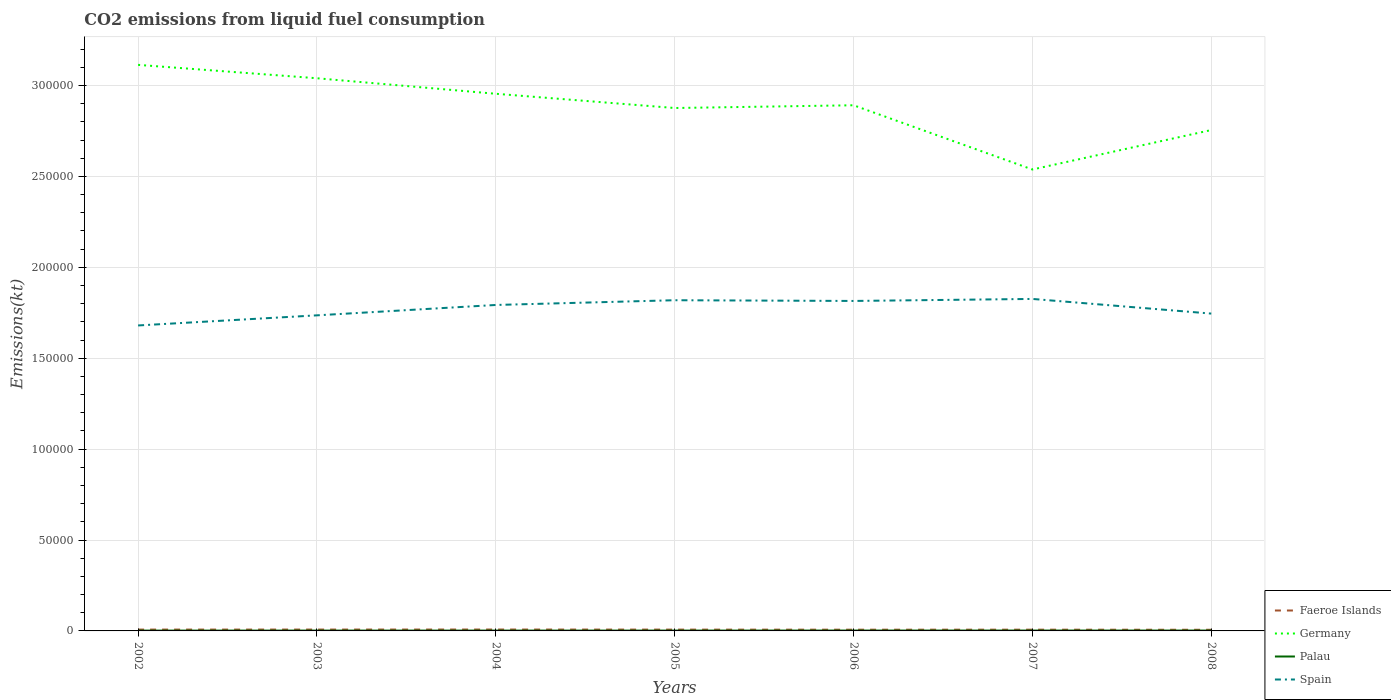How many different coloured lines are there?
Offer a terse response. 4. Across all years, what is the maximum amount of CO2 emitted in Faeroe Islands?
Make the answer very short. 630.72. In which year was the amount of CO2 emitted in Germany maximum?
Your answer should be compact. 2007. What is the total amount of CO2 emitted in Palau in the graph?
Offer a terse response. -18.34. What is the difference between the highest and the second highest amount of CO2 emitted in Palau?
Your answer should be compact. 25.67. What is the difference between the highest and the lowest amount of CO2 emitted in Germany?
Your answer should be very brief. 4. Does the graph contain any zero values?
Your answer should be very brief. No. Does the graph contain grids?
Offer a terse response. Yes. How many legend labels are there?
Your response must be concise. 4. How are the legend labels stacked?
Your answer should be very brief. Vertical. What is the title of the graph?
Your response must be concise. CO2 emissions from liquid fuel consumption. What is the label or title of the X-axis?
Make the answer very short. Years. What is the label or title of the Y-axis?
Give a very brief answer. Emissions(kt). What is the Emissions(kt) of Faeroe Islands in 2002?
Provide a short and direct response. 733.4. What is the Emissions(kt) in Germany in 2002?
Offer a very short reply. 3.11e+05. What is the Emissions(kt) in Palau in 2002?
Your answer should be very brief. 183.35. What is the Emissions(kt) of Spain in 2002?
Provide a short and direct response. 1.68e+05. What is the Emissions(kt) in Faeroe Islands in 2003?
Offer a very short reply. 748.07. What is the Emissions(kt) of Germany in 2003?
Keep it short and to the point. 3.04e+05. What is the Emissions(kt) in Palau in 2003?
Offer a very short reply. 190.68. What is the Emissions(kt) in Spain in 2003?
Ensure brevity in your answer.  1.74e+05. What is the Emissions(kt) of Faeroe Islands in 2004?
Keep it short and to the point. 766.4. What is the Emissions(kt) of Germany in 2004?
Keep it short and to the point. 2.95e+05. What is the Emissions(kt) of Palau in 2004?
Keep it short and to the point. 187.02. What is the Emissions(kt) in Spain in 2004?
Offer a terse response. 1.79e+05. What is the Emissions(kt) in Faeroe Islands in 2005?
Ensure brevity in your answer.  722.4. What is the Emissions(kt) of Germany in 2005?
Keep it short and to the point. 2.88e+05. What is the Emissions(kt) of Palau in 2005?
Offer a terse response. 190.68. What is the Emissions(kt) in Spain in 2005?
Ensure brevity in your answer.  1.82e+05. What is the Emissions(kt) in Faeroe Islands in 2006?
Your response must be concise. 678.39. What is the Emissions(kt) of Germany in 2006?
Keep it short and to the point. 2.89e+05. What is the Emissions(kt) in Palau in 2006?
Give a very brief answer. 201.69. What is the Emissions(kt) in Spain in 2006?
Provide a short and direct response. 1.82e+05. What is the Emissions(kt) in Faeroe Islands in 2007?
Provide a short and direct response. 689.4. What is the Emissions(kt) of Germany in 2007?
Ensure brevity in your answer.  2.54e+05. What is the Emissions(kt) of Palau in 2007?
Your answer should be very brief. 209.02. What is the Emissions(kt) in Spain in 2007?
Provide a succinct answer. 1.83e+05. What is the Emissions(kt) of Faeroe Islands in 2008?
Your answer should be compact. 630.72. What is the Emissions(kt) of Germany in 2008?
Provide a succinct answer. 2.76e+05. What is the Emissions(kt) of Palau in 2008?
Ensure brevity in your answer.  209.02. What is the Emissions(kt) of Spain in 2008?
Your response must be concise. 1.75e+05. Across all years, what is the maximum Emissions(kt) of Faeroe Islands?
Offer a terse response. 766.4. Across all years, what is the maximum Emissions(kt) in Germany?
Offer a terse response. 3.11e+05. Across all years, what is the maximum Emissions(kt) of Palau?
Offer a terse response. 209.02. Across all years, what is the maximum Emissions(kt) of Spain?
Your answer should be very brief. 1.83e+05. Across all years, what is the minimum Emissions(kt) of Faeroe Islands?
Ensure brevity in your answer.  630.72. Across all years, what is the minimum Emissions(kt) of Germany?
Ensure brevity in your answer.  2.54e+05. Across all years, what is the minimum Emissions(kt) in Palau?
Your answer should be very brief. 183.35. Across all years, what is the minimum Emissions(kt) in Spain?
Make the answer very short. 1.68e+05. What is the total Emissions(kt) of Faeroe Islands in the graph?
Offer a terse response. 4968.78. What is the total Emissions(kt) of Germany in the graph?
Offer a terse response. 2.02e+06. What is the total Emissions(kt) of Palau in the graph?
Make the answer very short. 1371.46. What is the total Emissions(kt) of Spain in the graph?
Ensure brevity in your answer.  1.24e+06. What is the difference between the Emissions(kt) of Faeroe Islands in 2002 and that in 2003?
Give a very brief answer. -14.67. What is the difference between the Emissions(kt) in Germany in 2002 and that in 2003?
Provide a short and direct response. 7367. What is the difference between the Emissions(kt) in Palau in 2002 and that in 2003?
Your response must be concise. -7.33. What is the difference between the Emissions(kt) of Spain in 2002 and that in 2003?
Your answer should be very brief. -5566.51. What is the difference between the Emissions(kt) in Faeroe Islands in 2002 and that in 2004?
Provide a succinct answer. -33. What is the difference between the Emissions(kt) in Germany in 2002 and that in 2004?
Ensure brevity in your answer.  1.59e+04. What is the difference between the Emissions(kt) in Palau in 2002 and that in 2004?
Keep it short and to the point. -3.67. What is the difference between the Emissions(kt) in Spain in 2002 and that in 2004?
Offer a very short reply. -1.13e+04. What is the difference between the Emissions(kt) of Faeroe Islands in 2002 and that in 2005?
Give a very brief answer. 11. What is the difference between the Emissions(kt) in Germany in 2002 and that in 2005?
Ensure brevity in your answer.  2.37e+04. What is the difference between the Emissions(kt) of Palau in 2002 and that in 2005?
Provide a succinct answer. -7.33. What is the difference between the Emissions(kt) in Spain in 2002 and that in 2005?
Provide a succinct answer. -1.39e+04. What is the difference between the Emissions(kt) in Faeroe Islands in 2002 and that in 2006?
Your answer should be very brief. 55.01. What is the difference between the Emissions(kt) of Germany in 2002 and that in 2006?
Keep it short and to the point. 2.22e+04. What is the difference between the Emissions(kt) of Palau in 2002 and that in 2006?
Give a very brief answer. -18.34. What is the difference between the Emissions(kt) of Spain in 2002 and that in 2006?
Keep it short and to the point. -1.35e+04. What is the difference between the Emissions(kt) in Faeroe Islands in 2002 and that in 2007?
Make the answer very short. 44. What is the difference between the Emissions(kt) of Germany in 2002 and that in 2007?
Offer a very short reply. 5.76e+04. What is the difference between the Emissions(kt) in Palau in 2002 and that in 2007?
Give a very brief answer. -25.67. What is the difference between the Emissions(kt) in Spain in 2002 and that in 2007?
Give a very brief answer. -1.46e+04. What is the difference between the Emissions(kt) of Faeroe Islands in 2002 and that in 2008?
Your answer should be compact. 102.68. What is the difference between the Emissions(kt) in Germany in 2002 and that in 2008?
Provide a succinct answer. 3.59e+04. What is the difference between the Emissions(kt) in Palau in 2002 and that in 2008?
Offer a terse response. -25.67. What is the difference between the Emissions(kt) in Spain in 2002 and that in 2008?
Provide a short and direct response. -6527.26. What is the difference between the Emissions(kt) in Faeroe Islands in 2003 and that in 2004?
Offer a very short reply. -18.34. What is the difference between the Emissions(kt) of Germany in 2003 and that in 2004?
Your response must be concise. 8536.78. What is the difference between the Emissions(kt) of Palau in 2003 and that in 2004?
Keep it short and to the point. 3.67. What is the difference between the Emissions(kt) in Spain in 2003 and that in 2004?
Offer a terse response. -5705.85. What is the difference between the Emissions(kt) in Faeroe Islands in 2003 and that in 2005?
Offer a very short reply. 25.67. What is the difference between the Emissions(kt) in Germany in 2003 and that in 2005?
Ensure brevity in your answer.  1.64e+04. What is the difference between the Emissions(kt) of Palau in 2003 and that in 2005?
Offer a very short reply. 0. What is the difference between the Emissions(kt) in Spain in 2003 and that in 2005?
Your answer should be compact. -8309.42. What is the difference between the Emissions(kt) in Faeroe Islands in 2003 and that in 2006?
Offer a very short reply. 69.67. What is the difference between the Emissions(kt) of Germany in 2003 and that in 2006?
Offer a terse response. 1.49e+04. What is the difference between the Emissions(kt) in Palau in 2003 and that in 2006?
Your answer should be very brief. -11. What is the difference between the Emissions(kt) of Spain in 2003 and that in 2006?
Your answer should be very brief. -7913.39. What is the difference between the Emissions(kt) of Faeroe Islands in 2003 and that in 2007?
Give a very brief answer. 58.67. What is the difference between the Emissions(kt) in Germany in 2003 and that in 2007?
Give a very brief answer. 5.02e+04. What is the difference between the Emissions(kt) of Palau in 2003 and that in 2007?
Keep it short and to the point. -18.34. What is the difference between the Emissions(kt) of Spain in 2003 and that in 2007?
Give a very brief answer. -9024.49. What is the difference between the Emissions(kt) of Faeroe Islands in 2003 and that in 2008?
Provide a succinct answer. 117.34. What is the difference between the Emissions(kt) of Germany in 2003 and that in 2008?
Make the answer very short. 2.85e+04. What is the difference between the Emissions(kt) of Palau in 2003 and that in 2008?
Your response must be concise. -18.34. What is the difference between the Emissions(kt) of Spain in 2003 and that in 2008?
Provide a succinct answer. -960.75. What is the difference between the Emissions(kt) in Faeroe Islands in 2004 and that in 2005?
Your response must be concise. 44. What is the difference between the Emissions(kt) of Germany in 2004 and that in 2005?
Provide a short and direct response. 7832.71. What is the difference between the Emissions(kt) of Palau in 2004 and that in 2005?
Provide a succinct answer. -3.67. What is the difference between the Emissions(kt) of Spain in 2004 and that in 2005?
Ensure brevity in your answer.  -2603.57. What is the difference between the Emissions(kt) in Faeroe Islands in 2004 and that in 2006?
Ensure brevity in your answer.  88.01. What is the difference between the Emissions(kt) of Germany in 2004 and that in 2006?
Provide a short and direct response. 6318.24. What is the difference between the Emissions(kt) in Palau in 2004 and that in 2006?
Your response must be concise. -14.67. What is the difference between the Emissions(kt) of Spain in 2004 and that in 2006?
Your response must be concise. -2207.53. What is the difference between the Emissions(kt) of Faeroe Islands in 2004 and that in 2007?
Your answer should be very brief. 77.01. What is the difference between the Emissions(kt) of Germany in 2004 and that in 2007?
Provide a succinct answer. 4.17e+04. What is the difference between the Emissions(kt) in Palau in 2004 and that in 2007?
Offer a terse response. -22. What is the difference between the Emissions(kt) in Spain in 2004 and that in 2007?
Provide a succinct answer. -3318.64. What is the difference between the Emissions(kt) of Faeroe Islands in 2004 and that in 2008?
Provide a short and direct response. 135.68. What is the difference between the Emissions(kt) in Germany in 2004 and that in 2008?
Offer a very short reply. 2.00e+04. What is the difference between the Emissions(kt) of Palau in 2004 and that in 2008?
Your response must be concise. -22. What is the difference between the Emissions(kt) of Spain in 2004 and that in 2008?
Provide a short and direct response. 4745.1. What is the difference between the Emissions(kt) of Faeroe Islands in 2005 and that in 2006?
Provide a short and direct response. 44. What is the difference between the Emissions(kt) in Germany in 2005 and that in 2006?
Keep it short and to the point. -1514.47. What is the difference between the Emissions(kt) in Palau in 2005 and that in 2006?
Give a very brief answer. -11. What is the difference between the Emissions(kt) of Spain in 2005 and that in 2006?
Your response must be concise. 396.04. What is the difference between the Emissions(kt) of Faeroe Islands in 2005 and that in 2007?
Your answer should be very brief. 33. What is the difference between the Emissions(kt) in Germany in 2005 and that in 2007?
Provide a short and direct response. 3.38e+04. What is the difference between the Emissions(kt) of Palau in 2005 and that in 2007?
Offer a terse response. -18.34. What is the difference between the Emissions(kt) of Spain in 2005 and that in 2007?
Offer a terse response. -715.07. What is the difference between the Emissions(kt) of Faeroe Islands in 2005 and that in 2008?
Provide a succinct answer. 91.67. What is the difference between the Emissions(kt) of Germany in 2005 and that in 2008?
Provide a short and direct response. 1.21e+04. What is the difference between the Emissions(kt) of Palau in 2005 and that in 2008?
Make the answer very short. -18.34. What is the difference between the Emissions(kt) of Spain in 2005 and that in 2008?
Provide a short and direct response. 7348.67. What is the difference between the Emissions(kt) of Faeroe Islands in 2006 and that in 2007?
Make the answer very short. -11. What is the difference between the Emissions(kt) in Germany in 2006 and that in 2007?
Your answer should be very brief. 3.53e+04. What is the difference between the Emissions(kt) of Palau in 2006 and that in 2007?
Your answer should be very brief. -7.33. What is the difference between the Emissions(kt) in Spain in 2006 and that in 2007?
Keep it short and to the point. -1111.1. What is the difference between the Emissions(kt) of Faeroe Islands in 2006 and that in 2008?
Keep it short and to the point. 47.67. What is the difference between the Emissions(kt) of Germany in 2006 and that in 2008?
Ensure brevity in your answer.  1.36e+04. What is the difference between the Emissions(kt) of Palau in 2006 and that in 2008?
Provide a short and direct response. -7.33. What is the difference between the Emissions(kt) of Spain in 2006 and that in 2008?
Your answer should be very brief. 6952.63. What is the difference between the Emissions(kt) in Faeroe Islands in 2007 and that in 2008?
Your answer should be very brief. 58.67. What is the difference between the Emissions(kt) of Germany in 2007 and that in 2008?
Offer a terse response. -2.17e+04. What is the difference between the Emissions(kt) of Spain in 2007 and that in 2008?
Make the answer very short. 8063.73. What is the difference between the Emissions(kt) of Faeroe Islands in 2002 and the Emissions(kt) of Germany in 2003?
Your answer should be very brief. -3.03e+05. What is the difference between the Emissions(kt) in Faeroe Islands in 2002 and the Emissions(kt) in Palau in 2003?
Your response must be concise. 542.72. What is the difference between the Emissions(kt) in Faeroe Islands in 2002 and the Emissions(kt) in Spain in 2003?
Your answer should be compact. -1.73e+05. What is the difference between the Emissions(kt) in Germany in 2002 and the Emissions(kt) in Palau in 2003?
Ensure brevity in your answer.  3.11e+05. What is the difference between the Emissions(kt) in Germany in 2002 and the Emissions(kt) in Spain in 2003?
Give a very brief answer. 1.38e+05. What is the difference between the Emissions(kt) in Palau in 2002 and the Emissions(kt) in Spain in 2003?
Ensure brevity in your answer.  -1.73e+05. What is the difference between the Emissions(kt) in Faeroe Islands in 2002 and the Emissions(kt) in Germany in 2004?
Ensure brevity in your answer.  -2.95e+05. What is the difference between the Emissions(kt) in Faeroe Islands in 2002 and the Emissions(kt) in Palau in 2004?
Provide a succinct answer. 546.38. What is the difference between the Emissions(kt) of Faeroe Islands in 2002 and the Emissions(kt) of Spain in 2004?
Ensure brevity in your answer.  -1.79e+05. What is the difference between the Emissions(kt) of Germany in 2002 and the Emissions(kt) of Palau in 2004?
Make the answer very short. 3.11e+05. What is the difference between the Emissions(kt) of Germany in 2002 and the Emissions(kt) of Spain in 2004?
Offer a terse response. 1.32e+05. What is the difference between the Emissions(kt) in Palau in 2002 and the Emissions(kt) in Spain in 2004?
Provide a succinct answer. -1.79e+05. What is the difference between the Emissions(kt) in Faeroe Islands in 2002 and the Emissions(kt) in Germany in 2005?
Make the answer very short. -2.87e+05. What is the difference between the Emissions(kt) in Faeroe Islands in 2002 and the Emissions(kt) in Palau in 2005?
Provide a short and direct response. 542.72. What is the difference between the Emissions(kt) in Faeroe Islands in 2002 and the Emissions(kt) in Spain in 2005?
Offer a very short reply. -1.81e+05. What is the difference between the Emissions(kt) of Germany in 2002 and the Emissions(kt) of Palau in 2005?
Make the answer very short. 3.11e+05. What is the difference between the Emissions(kt) of Germany in 2002 and the Emissions(kt) of Spain in 2005?
Your answer should be very brief. 1.29e+05. What is the difference between the Emissions(kt) of Palau in 2002 and the Emissions(kt) of Spain in 2005?
Give a very brief answer. -1.82e+05. What is the difference between the Emissions(kt) in Faeroe Islands in 2002 and the Emissions(kt) in Germany in 2006?
Provide a succinct answer. -2.88e+05. What is the difference between the Emissions(kt) in Faeroe Islands in 2002 and the Emissions(kt) in Palau in 2006?
Make the answer very short. 531.72. What is the difference between the Emissions(kt) of Faeroe Islands in 2002 and the Emissions(kt) of Spain in 2006?
Keep it short and to the point. -1.81e+05. What is the difference between the Emissions(kt) in Germany in 2002 and the Emissions(kt) in Palau in 2006?
Keep it short and to the point. 3.11e+05. What is the difference between the Emissions(kt) of Germany in 2002 and the Emissions(kt) of Spain in 2006?
Provide a short and direct response. 1.30e+05. What is the difference between the Emissions(kt) of Palau in 2002 and the Emissions(kt) of Spain in 2006?
Your answer should be very brief. -1.81e+05. What is the difference between the Emissions(kt) in Faeroe Islands in 2002 and the Emissions(kt) in Germany in 2007?
Provide a short and direct response. -2.53e+05. What is the difference between the Emissions(kt) in Faeroe Islands in 2002 and the Emissions(kt) in Palau in 2007?
Ensure brevity in your answer.  524.38. What is the difference between the Emissions(kt) of Faeroe Islands in 2002 and the Emissions(kt) of Spain in 2007?
Keep it short and to the point. -1.82e+05. What is the difference between the Emissions(kt) of Germany in 2002 and the Emissions(kt) of Palau in 2007?
Provide a short and direct response. 3.11e+05. What is the difference between the Emissions(kt) of Germany in 2002 and the Emissions(kt) of Spain in 2007?
Offer a very short reply. 1.29e+05. What is the difference between the Emissions(kt) in Palau in 2002 and the Emissions(kt) in Spain in 2007?
Provide a short and direct response. -1.82e+05. What is the difference between the Emissions(kt) in Faeroe Islands in 2002 and the Emissions(kt) in Germany in 2008?
Provide a short and direct response. -2.75e+05. What is the difference between the Emissions(kt) of Faeroe Islands in 2002 and the Emissions(kt) of Palau in 2008?
Offer a very short reply. 524.38. What is the difference between the Emissions(kt) of Faeroe Islands in 2002 and the Emissions(kt) of Spain in 2008?
Offer a very short reply. -1.74e+05. What is the difference between the Emissions(kt) in Germany in 2002 and the Emissions(kt) in Palau in 2008?
Give a very brief answer. 3.11e+05. What is the difference between the Emissions(kt) of Germany in 2002 and the Emissions(kt) of Spain in 2008?
Provide a succinct answer. 1.37e+05. What is the difference between the Emissions(kt) in Palau in 2002 and the Emissions(kt) in Spain in 2008?
Your answer should be very brief. -1.74e+05. What is the difference between the Emissions(kt) of Faeroe Islands in 2003 and the Emissions(kt) of Germany in 2004?
Keep it short and to the point. -2.95e+05. What is the difference between the Emissions(kt) in Faeroe Islands in 2003 and the Emissions(kt) in Palau in 2004?
Make the answer very short. 561.05. What is the difference between the Emissions(kt) in Faeroe Islands in 2003 and the Emissions(kt) in Spain in 2004?
Ensure brevity in your answer.  -1.79e+05. What is the difference between the Emissions(kt) in Germany in 2003 and the Emissions(kt) in Palau in 2004?
Provide a short and direct response. 3.04e+05. What is the difference between the Emissions(kt) in Germany in 2003 and the Emissions(kt) in Spain in 2004?
Provide a short and direct response. 1.25e+05. What is the difference between the Emissions(kt) of Palau in 2003 and the Emissions(kt) of Spain in 2004?
Make the answer very short. -1.79e+05. What is the difference between the Emissions(kt) in Faeroe Islands in 2003 and the Emissions(kt) in Germany in 2005?
Your answer should be very brief. -2.87e+05. What is the difference between the Emissions(kt) in Faeroe Islands in 2003 and the Emissions(kt) in Palau in 2005?
Offer a terse response. 557.38. What is the difference between the Emissions(kt) of Faeroe Islands in 2003 and the Emissions(kt) of Spain in 2005?
Provide a succinct answer. -1.81e+05. What is the difference between the Emissions(kt) of Germany in 2003 and the Emissions(kt) of Palau in 2005?
Provide a short and direct response. 3.04e+05. What is the difference between the Emissions(kt) in Germany in 2003 and the Emissions(kt) in Spain in 2005?
Provide a short and direct response. 1.22e+05. What is the difference between the Emissions(kt) of Palau in 2003 and the Emissions(kt) of Spain in 2005?
Your response must be concise. -1.82e+05. What is the difference between the Emissions(kt) in Faeroe Islands in 2003 and the Emissions(kt) in Germany in 2006?
Ensure brevity in your answer.  -2.88e+05. What is the difference between the Emissions(kt) in Faeroe Islands in 2003 and the Emissions(kt) in Palau in 2006?
Provide a succinct answer. 546.38. What is the difference between the Emissions(kt) in Faeroe Islands in 2003 and the Emissions(kt) in Spain in 2006?
Provide a short and direct response. -1.81e+05. What is the difference between the Emissions(kt) in Germany in 2003 and the Emissions(kt) in Palau in 2006?
Give a very brief answer. 3.04e+05. What is the difference between the Emissions(kt) in Germany in 2003 and the Emissions(kt) in Spain in 2006?
Keep it short and to the point. 1.22e+05. What is the difference between the Emissions(kt) in Palau in 2003 and the Emissions(kt) in Spain in 2006?
Provide a succinct answer. -1.81e+05. What is the difference between the Emissions(kt) in Faeroe Islands in 2003 and the Emissions(kt) in Germany in 2007?
Ensure brevity in your answer.  -2.53e+05. What is the difference between the Emissions(kt) of Faeroe Islands in 2003 and the Emissions(kt) of Palau in 2007?
Offer a terse response. 539.05. What is the difference between the Emissions(kt) in Faeroe Islands in 2003 and the Emissions(kt) in Spain in 2007?
Offer a very short reply. -1.82e+05. What is the difference between the Emissions(kt) in Germany in 2003 and the Emissions(kt) in Palau in 2007?
Offer a very short reply. 3.04e+05. What is the difference between the Emissions(kt) in Germany in 2003 and the Emissions(kt) in Spain in 2007?
Ensure brevity in your answer.  1.21e+05. What is the difference between the Emissions(kt) in Palau in 2003 and the Emissions(kt) in Spain in 2007?
Provide a short and direct response. -1.82e+05. What is the difference between the Emissions(kt) of Faeroe Islands in 2003 and the Emissions(kt) of Germany in 2008?
Provide a succinct answer. -2.75e+05. What is the difference between the Emissions(kt) of Faeroe Islands in 2003 and the Emissions(kt) of Palau in 2008?
Ensure brevity in your answer.  539.05. What is the difference between the Emissions(kt) in Faeroe Islands in 2003 and the Emissions(kt) in Spain in 2008?
Give a very brief answer. -1.74e+05. What is the difference between the Emissions(kt) in Germany in 2003 and the Emissions(kt) in Palau in 2008?
Give a very brief answer. 3.04e+05. What is the difference between the Emissions(kt) of Germany in 2003 and the Emissions(kt) of Spain in 2008?
Make the answer very short. 1.29e+05. What is the difference between the Emissions(kt) of Palau in 2003 and the Emissions(kt) of Spain in 2008?
Your response must be concise. -1.74e+05. What is the difference between the Emissions(kt) of Faeroe Islands in 2004 and the Emissions(kt) of Germany in 2005?
Make the answer very short. -2.87e+05. What is the difference between the Emissions(kt) of Faeroe Islands in 2004 and the Emissions(kt) of Palau in 2005?
Your answer should be very brief. 575.72. What is the difference between the Emissions(kt) of Faeroe Islands in 2004 and the Emissions(kt) of Spain in 2005?
Provide a short and direct response. -1.81e+05. What is the difference between the Emissions(kt) of Germany in 2004 and the Emissions(kt) of Palau in 2005?
Make the answer very short. 2.95e+05. What is the difference between the Emissions(kt) of Germany in 2004 and the Emissions(kt) of Spain in 2005?
Your answer should be compact. 1.14e+05. What is the difference between the Emissions(kt) in Palau in 2004 and the Emissions(kt) in Spain in 2005?
Your answer should be compact. -1.82e+05. What is the difference between the Emissions(kt) in Faeroe Islands in 2004 and the Emissions(kt) in Germany in 2006?
Provide a succinct answer. -2.88e+05. What is the difference between the Emissions(kt) in Faeroe Islands in 2004 and the Emissions(kt) in Palau in 2006?
Your response must be concise. 564.72. What is the difference between the Emissions(kt) in Faeroe Islands in 2004 and the Emissions(kt) in Spain in 2006?
Provide a succinct answer. -1.81e+05. What is the difference between the Emissions(kt) of Germany in 2004 and the Emissions(kt) of Palau in 2006?
Offer a terse response. 2.95e+05. What is the difference between the Emissions(kt) of Germany in 2004 and the Emissions(kt) of Spain in 2006?
Provide a short and direct response. 1.14e+05. What is the difference between the Emissions(kt) of Palau in 2004 and the Emissions(kt) of Spain in 2006?
Offer a terse response. -1.81e+05. What is the difference between the Emissions(kt) of Faeroe Islands in 2004 and the Emissions(kt) of Germany in 2007?
Make the answer very short. -2.53e+05. What is the difference between the Emissions(kt) in Faeroe Islands in 2004 and the Emissions(kt) in Palau in 2007?
Keep it short and to the point. 557.38. What is the difference between the Emissions(kt) of Faeroe Islands in 2004 and the Emissions(kt) of Spain in 2007?
Offer a terse response. -1.82e+05. What is the difference between the Emissions(kt) in Germany in 2004 and the Emissions(kt) in Palau in 2007?
Offer a terse response. 2.95e+05. What is the difference between the Emissions(kt) of Germany in 2004 and the Emissions(kt) of Spain in 2007?
Offer a terse response. 1.13e+05. What is the difference between the Emissions(kt) of Palau in 2004 and the Emissions(kt) of Spain in 2007?
Provide a short and direct response. -1.82e+05. What is the difference between the Emissions(kt) in Faeroe Islands in 2004 and the Emissions(kt) in Germany in 2008?
Ensure brevity in your answer.  -2.75e+05. What is the difference between the Emissions(kt) in Faeroe Islands in 2004 and the Emissions(kt) in Palau in 2008?
Ensure brevity in your answer.  557.38. What is the difference between the Emissions(kt) in Faeroe Islands in 2004 and the Emissions(kt) in Spain in 2008?
Your response must be concise. -1.74e+05. What is the difference between the Emissions(kt) of Germany in 2004 and the Emissions(kt) of Palau in 2008?
Ensure brevity in your answer.  2.95e+05. What is the difference between the Emissions(kt) in Germany in 2004 and the Emissions(kt) in Spain in 2008?
Give a very brief answer. 1.21e+05. What is the difference between the Emissions(kt) in Palau in 2004 and the Emissions(kt) in Spain in 2008?
Give a very brief answer. -1.74e+05. What is the difference between the Emissions(kt) of Faeroe Islands in 2005 and the Emissions(kt) of Germany in 2006?
Your answer should be very brief. -2.88e+05. What is the difference between the Emissions(kt) of Faeroe Islands in 2005 and the Emissions(kt) of Palau in 2006?
Give a very brief answer. 520.71. What is the difference between the Emissions(kt) of Faeroe Islands in 2005 and the Emissions(kt) of Spain in 2006?
Give a very brief answer. -1.81e+05. What is the difference between the Emissions(kt) of Germany in 2005 and the Emissions(kt) of Palau in 2006?
Offer a very short reply. 2.87e+05. What is the difference between the Emissions(kt) of Germany in 2005 and the Emissions(kt) of Spain in 2006?
Your answer should be compact. 1.06e+05. What is the difference between the Emissions(kt) of Palau in 2005 and the Emissions(kt) of Spain in 2006?
Provide a succinct answer. -1.81e+05. What is the difference between the Emissions(kt) in Faeroe Islands in 2005 and the Emissions(kt) in Germany in 2007?
Ensure brevity in your answer.  -2.53e+05. What is the difference between the Emissions(kt) of Faeroe Islands in 2005 and the Emissions(kt) of Palau in 2007?
Offer a very short reply. 513.38. What is the difference between the Emissions(kt) in Faeroe Islands in 2005 and the Emissions(kt) in Spain in 2007?
Offer a very short reply. -1.82e+05. What is the difference between the Emissions(kt) of Germany in 2005 and the Emissions(kt) of Palau in 2007?
Provide a short and direct response. 2.87e+05. What is the difference between the Emissions(kt) of Germany in 2005 and the Emissions(kt) of Spain in 2007?
Make the answer very short. 1.05e+05. What is the difference between the Emissions(kt) in Palau in 2005 and the Emissions(kt) in Spain in 2007?
Provide a succinct answer. -1.82e+05. What is the difference between the Emissions(kt) of Faeroe Islands in 2005 and the Emissions(kt) of Germany in 2008?
Provide a short and direct response. -2.75e+05. What is the difference between the Emissions(kt) of Faeroe Islands in 2005 and the Emissions(kt) of Palau in 2008?
Provide a short and direct response. 513.38. What is the difference between the Emissions(kt) in Faeroe Islands in 2005 and the Emissions(kt) in Spain in 2008?
Give a very brief answer. -1.74e+05. What is the difference between the Emissions(kt) of Germany in 2005 and the Emissions(kt) of Palau in 2008?
Give a very brief answer. 2.87e+05. What is the difference between the Emissions(kt) of Germany in 2005 and the Emissions(kt) of Spain in 2008?
Make the answer very short. 1.13e+05. What is the difference between the Emissions(kt) of Palau in 2005 and the Emissions(kt) of Spain in 2008?
Give a very brief answer. -1.74e+05. What is the difference between the Emissions(kt) in Faeroe Islands in 2006 and the Emissions(kt) in Germany in 2007?
Offer a terse response. -2.53e+05. What is the difference between the Emissions(kt) of Faeroe Islands in 2006 and the Emissions(kt) of Palau in 2007?
Make the answer very short. 469.38. What is the difference between the Emissions(kt) in Faeroe Islands in 2006 and the Emissions(kt) in Spain in 2007?
Your response must be concise. -1.82e+05. What is the difference between the Emissions(kt) of Germany in 2006 and the Emissions(kt) of Palau in 2007?
Ensure brevity in your answer.  2.89e+05. What is the difference between the Emissions(kt) of Germany in 2006 and the Emissions(kt) of Spain in 2007?
Offer a very short reply. 1.07e+05. What is the difference between the Emissions(kt) of Palau in 2006 and the Emissions(kt) of Spain in 2007?
Your answer should be compact. -1.82e+05. What is the difference between the Emissions(kt) in Faeroe Islands in 2006 and the Emissions(kt) in Germany in 2008?
Provide a succinct answer. -2.75e+05. What is the difference between the Emissions(kt) in Faeroe Islands in 2006 and the Emissions(kt) in Palau in 2008?
Provide a succinct answer. 469.38. What is the difference between the Emissions(kt) in Faeroe Islands in 2006 and the Emissions(kt) in Spain in 2008?
Provide a short and direct response. -1.74e+05. What is the difference between the Emissions(kt) in Germany in 2006 and the Emissions(kt) in Palau in 2008?
Offer a very short reply. 2.89e+05. What is the difference between the Emissions(kt) of Germany in 2006 and the Emissions(kt) of Spain in 2008?
Provide a short and direct response. 1.15e+05. What is the difference between the Emissions(kt) of Palau in 2006 and the Emissions(kt) of Spain in 2008?
Provide a short and direct response. -1.74e+05. What is the difference between the Emissions(kt) of Faeroe Islands in 2007 and the Emissions(kt) of Germany in 2008?
Give a very brief answer. -2.75e+05. What is the difference between the Emissions(kt) in Faeroe Islands in 2007 and the Emissions(kt) in Palau in 2008?
Your answer should be compact. 480.38. What is the difference between the Emissions(kt) of Faeroe Islands in 2007 and the Emissions(kt) of Spain in 2008?
Offer a very short reply. -1.74e+05. What is the difference between the Emissions(kt) of Germany in 2007 and the Emissions(kt) of Palau in 2008?
Your response must be concise. 2.54e+05. What is the difference between the Emissions(kt) of Germany in 2007 and the Emissions(kt) of Spain in 2008?
Make the answer very short. 7.93e+04. What is the difference between the Emissions(kt) of Palau in 2007 and the Emissions(kt) of Spain in 2008?
Offer a very short reply. -1.74e+05. What is the average Emissions(kt) of Faeroe Islands per year?
Make the answer very short. 709.83. What is the average Emissions(kt) of Germany per year?
Offer a terse response. 2.88e+05. What is the average Emissions(kt) in Palau per year?
Provide a succinct answer. 195.92. What is the average Emissions(kt) of Spain per year?
Your response must be concise. 1.77e+05. In the year 2002, what is the difference between the Emissions(kt) of Faeroe Islands and Emissions(kt) of Germany?
Ensure brevity in your answer.  -3.11e+05. In the year 2002, what is the difference between the Emissions(kt) of Faeroe Islands and Emissions(kt) of Palau?
Ensure brevity in your answer.  550.05. In the year 2002, what is the difference between the Emissions(kt) of Faeroe Islands and Emissions(kt) of Spain?
Provide a succinct answer. -1.67e+05. In the year 2002, what is the difference between the Emissions(kt) in Germany and Emissions(kt) in Palau?
Offer a very short reply. 3.11e+05. In the year 2002, what is the difference between the Emissions(kt) in Germany and Emissions(kt) in Spain?
Your answer should be compact. 1.43e+05. In the year 2002, what is the difference between the Emissions(kt) of Palau and Emissions(kt) of Spain?
Ensure brevity in your answer.  -1.68e+05. In the year 2003, what is the difference between the Emissions(kt) of Faeroe Islands and Emissions(kt) of Germany?
Ensure brevity in your answer.  -3.03e+05. In the year 2003, what is the difference between the Emissions(kt) of Faeroe Islands and Emissions(kt) of Palau?
Offer a terse response. 557.38. In the year 2003, what is the difference between the Emissions(kt) in Faeroe Islands and Emissions(kt) in Spain?
Offer a terse response. -1.73e+05. In the year 2003, what is the difference between the Emissions(kt) of Germany and Emissions(kt) of Palau?
Offer a very short reply. 3.04e+05. In the year 2003, what is the difference between the Emissions(kt) of Germany and Emissions(kt) of Spain?
Provide a short and direct response. 1.30e+05. In the year 2003, what is the difference between the Emissions(kt) in Palau and Emissions(kt) in Spain?
Keep it short and to the point. -1.73e+05. In the year 2004, what is the difference between the Emissions(kt) of Faeroe Islands and Emissions(kt) of Germany?
Your response must be concise. -2.95e+05. In the year 2004, what is the difference between the Emissions(kt) of Faeroe Islands and Emissions(kt) of Palau?
Ensure brevity in your answer.  579.39. In the year 2004, what is the difference between the Emissions(kt) of Faeroe Islands and Emissions(kt) of Spain?
Your answer should be compact. -1.79e+05. In the year 2004, what is the difference between the Emissions(kt) in Germany and Emissions(kt) in Palau?
Your response must be concise. 2.95e+05. In the year 2004, what is the difference between the Emissions(kt) of Germany and Emissions(kt) of Spain?
Your answer should be very brief. 1.16e+05. In the year 2004, what is the difference between the Emissions(kt) of Palau and Emissions(kt) of Spain?
Ensure brevity in your answer.  -1.79e+05. In the year 2005, what is the difference between the Emissions(kt) in Faeroe Islands and Emissions(kt) in Germany?
Offer a very short reply. -2.87e+05. In the year 2005, what is the difference between the Emissions(kt) in Faeroe Islands and Emissions(kt) in Palau?
Your answer should be very brief. 531.72. In the year 2005, what is the difference between the Emissions(kt) in Faeroe Islands and Emissions(kt) in Spain?
Provide a short and direct response. -1.81e+05. In the year 2005, what is the difference between the Emissions(kt) of Germany and Emissions(kt) of Palau?
Your response must be concise. 2.87e+05. In the year 2005, what is the difference between the Emissions(kt) in Germany and Emissions(kt) in Spain?
Provide a succinct answer. 1.06e+05. In the year 2005, what is the difference between the Emissions(kt) in Palau and Emissions(kt) in Spain?
Offer a very short reply. -1.82e+05. In the year 2006, what is the difference between the Emissions(kt) in Faeroe Islands and Emissions(kt) in Germany?
Give a very brief answer. -2.88e+05. In the year 2006, what is the difference between the Emissions(kt) in Faeroe Islands and Emissions(kt) in Palau?
Provide a succinct answer. 476.71. In the year 2006, what is the difference between the Emissions(kt) of Faeroe Islands and Emissions(kt) of Spain?
Ensure brevity in your answer.  -1.81e+05. In the year 2006, what is the difference between the Emissions(kt) of Germany and Emissions(kt) of Palau?
Your response must be concise. 2.89e+05. In the year 2006, what is the difference between the Emissions(kt) in Germany and Emissions(kt) in Spain?
Provide a succinct answer. 1.08e+05. In the year 2006, what is the difference between the Emissions(kt) of Palau and Emissions(kt) of Spain?
Offer a very short reply. -1.81e+05. In the year 2007, what is the difference between the Emissions(kt) in Faeroe Islands and Emissions(kt) in Germany?
Offer a very short reply. -2.53e+05. In the year 2007, what is the difference between the Emissions(kt) of Faeroe Islands and Emissions(kt) of Palau?
Your answer should be very brief. 480.38. In the year 2007, what is the difference between the Emissions(kt) in Faeroe Islands and Emissions(kt) in Spain?
Your answer should be very brief. -1.82e+05. In the year 2007, what is the difference between the Emissions(kt) in Germany and Emissions(kt) in Palau?
Offer a terse response. 2.54e+05. In the year 2007, what is the difference between the Emissions(kt) in Germany and Emissions(kt) in Spain?
Provide a succinct answer. 7.12e+04. In the year 2007, what is the difference between the Emissions(kt) in Palau and Emissions(kt) in Spain?
Your response must be concise. -1.82e+05. In the year 2008, what is the difference between the Emissions(kt) in Faeroe Islands and Emissions(kt) in Germany?
Your answer should be compact. -2.75e+05. In the year 2008, what is the difference between the Emissions(kt) of Faeroe Islands and Emissions(kt) of Palau?
Your answer should be compact. 421.7. In the year 2008, what is the difference between the Emissions(kt) in Faeroe Islands and Emissions(kt) in Spain?
Make the answer very short. -1.74e+05. In the year 2008, what is the difference between the Emissions(kt) in Germany and Emissions(kt) in Palau?
Offer a very short reply. 2.75e+05. In the year 2008, what is the difference between the Emissions(kt) in Germany and Emissions(kt) in Spain?
Give a very brief answer. 1.01e+05. In the year 2008, what is the difference between the Emissions(kt) of Palau and Emissions(kt) of Spain?
Offer a terse response. -1.74e+05. What is the ratio of the Emissions(kt) in Faeroe Islands in 2002 to that in 2003?
Provide a succinct answer. 0.98. What is the ratio of the Emissions(kt) of Germany in 2002 to that in 2003?
Ensure brevity in your answer.  1.02. What is the ratio of the Emissions(kt) in Palau in 2002 to that in 2003?
Provide a succinct answer. 0.96. What is the ratio of the Emissions(kt) in Spain in 2002 to that in 2003?
Your response must be concise. 0.97. What is the ratio of the Emissions(kt) of Faeroe Islands in 2002 to that in 2004?
Keep it short and to the point. 0.96. What is the ratio of the Emissions(kt) in Germany in 2002 to that in 2004?
Your response must be concise. 1.05. What is the ratio of the Emissions(kt) in Palau in 2002 to that in 2004?
Your response must be concise. 0.98. What is the ratio of the Emissions(kt) of Spain in 2002 to that in 2004?
Make the answer very short. 0.94. What is the ratio of the Emissions(kt) of Faeroe Islands in 2002 to that in 2005?
Provide a succinct answer. 1.02. What is the ratio of the Emissions(kt) of Germany in 2002 to that in 2005?
Offer a very short reply. 1.08. What is the ratio of the Emissions(kt) in Palau in 2002 to that in 2005?
Your answer should be very brief. 0.96. What is the ratio of the Emissions(kt) of Spain in 2002 to that in 2005?
Your answer should be very brief. 0.92. What is the ratio of the Emissions(kt) in Faeroe Islands in 2002 to that in 2006?
Your answer should be compact. 1.08. What is the ratio of the Emissions(kt) in Germany in 2002 to that in 2006?
Your response must be concise. 1.08. What is the ratio of the Emissions(kt) of Palau in 2002 to that in 2006?
Your answer should be compact. 0.91. What is the ratio of the Emissions(kt) of Spain in 2002 to that in 2006?
Provide a succinct answer. 0.93. What is the ratio of the Emissions(kt) of Faeroe Islands in 2002 to that in 2007?
Your answer should be compact. 1.06. What is the ratio of the Emissions(kt) in Germany in 2002 to that in 2007?
Make the answer very short. 1.23. What is the ratio of the Emissions(kt) of Palau in 2002 to that in 2007?
Your response must be concise. 0.88. What is the ratio of the Emissions(kt) in Spain in 2002 to that in 2007?
Your answer should be compact. 0.92. What is the ratio of the Emissions(kt) in Faeroe Islands in 2002 to that in 2008?
Your answer should be compact. 1.16. What is the ratio of the Emissions(kt) of Germany in 2002 to that in 2008?
Your answer should be very brief. 1.13. What is the ratio of the Emissions(kt) in Palau in 2002 to that in 2008?
Provide a short and direct response. 0.88. What is the ratio of the Emissions(kt) of Spain in 2002 to that in 2008?
Your response must be concise. 0.96. What is the ratio of the Emissions(kt) of Faeroe Islands in 2003 to that in 2004?
Offer a terse response. 0.98. What is the ratio of the Emissions(kt) of Germany in 2003 to that in 2004?
Keep it short and to the point. 1.03. What is the ratio of the Emissions(kt) of Palau in 2003 to that in 2004?
Your answer should be compact. 1.02. What is the ratio of the Emissions(kt) in Spain in 2003 to that in 2004?
Your answer should be very brief. 0.97. What is the ratio of the Emissions(kt) of Faeroe Islands in 2003 to that in 2005?
Make the answer very short. 1.04. What is the ratio of the Emissions(kt) of Germany in 2003 to that in 2005?
Your response must be concise. 1.06. What is the ratio of the Emissions(kt) of Palau in 2003 to that in 2005?
Offer a very short reply. 1. What is the ratio of the Emissions(kt) in Spain in 2003 to that in 2005?
Your answer should be compact. 0.95. What is the ratio of the Emissions(kt) of Faeroe Islands in 2003 to that in 2006?
Give a very brief answer. 1.1. What is the ratio of the Emissions(kt) of Germany in 2003 to that in 2006?
Your answer should be very brief. 1.05. What is the ratio of the Emissions(kt) in Palau in 2003 to that in 2006?
Keep it short and to the point. 0.95. What is the ratio of the Emissions(kt) of Spain in 2003 to that in 2006?
Your answer should be very brief. 0.96. What is the ratio of the Emissions(kt) in Faeroe Islands in 2003 to that in 2007?
Offer a very short reply. 1.09. What is the ratio of the Emissions(kt) of Germany in 2003 to that in 2007?
Make the answer very short. 1.2. What is the ratio of the Emissions(kt) in Palau in 2003 to that in 2007?
Your answer should be compact. 0.91. What is the ratio of the Emissions(kt) of Spain in 2003 to that in 2007?
Your response must be concise. 0.95. What is the ratio of the Emissions(kt) in Faeroe Islands in 2003 to that in 2008?
Provide a succinct answer. 1.19. What is the ratio of the Emissions(kt) in Germany in 2003 to that in 2008?
Give a very brief answer. 1.1. What is the ratio of the Emissions(kt) in Palau in 2003 to that in 2008?
Ensure brevity in your answer.  0.91. What is the ratio of the Emissions(kt) of Faeroe Islands in 2004 to that in 2005?
Give a very brief answer. 1.06. What is the ratio of the Emissions(kt) of Germany in 2004 to that in 2005?
Give a very brief answer. 1.03. What is the ratio of the Emissions(kt) of Palau in 2004 to that in 2005?
Offer a terse response. 0.98. What is the ratio of the Emissions(kt) of Spain in 2004 to that in 2005?
Your answer should be very brief. 0.99. What is the ratio of the Emissions(kt) of Faeroe Islands in 2004 to that in 2006?
Make the answer very short. 1.13. What is the ratio of the Emissions(kt) of Germany in 2004 to that in 2006?
Your response must be concise. 1.02. What is the ratio of the Emissions(kt) of Palau in 2004 to that in 2006?
Your answer should be compact. 0.93. What is the ratio of the Emissions(kt) in Faeroe Islands in 2004 to that in 2007?
Provide a succinct answer. 1.11. What is the ratio of the Emissions(kt) in Germany in 2004 to that in 2007?
Offer a very short reply. 1.16. What is the ratio of the Emissions(kt) of Palau in 2004 to that in 2007?
Your answer should be compact. 0.89. What is the ratio of the Emissions(kt) of Spain in 2004 to that in 2007?
Provide a short and direct response. 0.98. What is the ratio of the Emissions(kt) in Faeroe Islands in 2004 to that in 2008?
Offer a terse response. 1.22. What is the ratio of the Emissions(kt) in Germany in 2004 to that in 2008?
Provide a short and direct response. 1.07. What is the ratio of the Emissions(kt) of Palau in 2004 to that in 2008?
Offer a terse response. 0.89. What is the ratio of the Emissions(kt) of Spain in 2004 to that in 2008?
Keep it short and to the point. 1.03. What is the ratio of the Emissions(kt) of Faeroe Islands in 2005 to that in 2006?
Keep it short and to the point. 1.06. What is the ratio of the Emissions(kt) in Germany in 2005 to that in 2006?
Your answer should be very brief. 0.99. What is the ratio of the Emissions(kt) in Palau in 2005 to that in 2006?
Your response must be concise. 0.95. What is the ratio of the Emissions(kt) in Faeroe Islands in 2005 to that in 2007?
Your answer should be compact. 1.05. What is the ratio of the Emissions(kt) of Germany in 2005 to that in 2007?
Provide a succinct answer. 1.13. What is the ratio of the Emissions(kt) of Palau in 2005 to that in 2007?
Ensure brevity in your answer.  0.91. What is the ratio of the Emissions(kt) of Faeroe Islands in 2005 to that in 2008?
Give a very brief answer. 1.15. What is the ratio of the Emissions(kt) of Germany in 2005 to that in 2008?
Your response must be concise. 1.04. What is the ratio of the Emissions(kt) of Palau in 2005 to that in 2008?
Offer a terse response. 0.91. What is the ratio of the Emissions(kt) of Spain in 2005 to that in 2008?
Your answer should be compact. 1.04. What is the ratio of the Emissions(kt) in Germany in 2006 to that in 2007?
Make the answer very short. 1.14. What is the ratio of the Emissions(kt) in Palau in 2006 to that in 2007?
Give a very brief answer. 0.96. What is the ratio of the Emissions(kt) of Spain in 2006 to that in 2007?
Ensure brevity in your answer.  0.99. What is the ratio of the Emissions(kt) in Faeroe Islands in 2006 to that in 2008?
Make the answer very short. 1.08. What is the ratio of the Emissions(kt) of Germany in 2006 to that in 2008?
Your response must be concise. 1.05. What is the ratio of the Emissions(kt) of Palau in 2006 to that in 2008?
Give a very brief answer. 0.96. What is the ratio of the Emissions(kt) in Spain in 2006 to that in 2008?
Provide a short and direct response. 1.04. What is the ratio of the Emissions(kt) of Faeroe Islands in 2007 to that in 2008?
Your response must be concise. 1.09. What is the ratio of the Emissions(kt) of Germany in 2007 to that in 2008?
Make the answer very short. 0.92. What is the ratio of the Emissions(kt) of Palau in 2007 to that in 2008?
Offer a very short reply. 1. What is the ratio of the Emissions(kt) in Spain in 2007 to that in 2008?
Keep it short and to the point. 1.05. What is the difference between the highest and the second highest Emissions(kt) in Faeroe Islands?
Make the answer very short. 18.34. What is the difference between the highest and the second highest Emissions(kt) in Germany?
Keep it short and to the point. 7367. What is the difference between the highest and the second highest Emissions(kt) of Palau?
Your response must be concise. 0. What is the difference between the highest and the second highest Emissions(kt) of Spain?
Your answer should be very brief. 715.07. What is the difference between the highest and the lowest Emissions(kt) of Faeroe Islands?
Ensure brevity in your answer.  135.68. What is the difference between the highest and the lowest Emissions(kt) of Germany?
Your answer should be very brief. 5.76e+04. What is the difference between the highest and the lowest Emissions(kt) of Palau?
Provide a succinct answer. 25.67. What is the difference between the highest and the lowest Emissions(kt) of Spain?
Offer a terse response. 1.46e+04. 